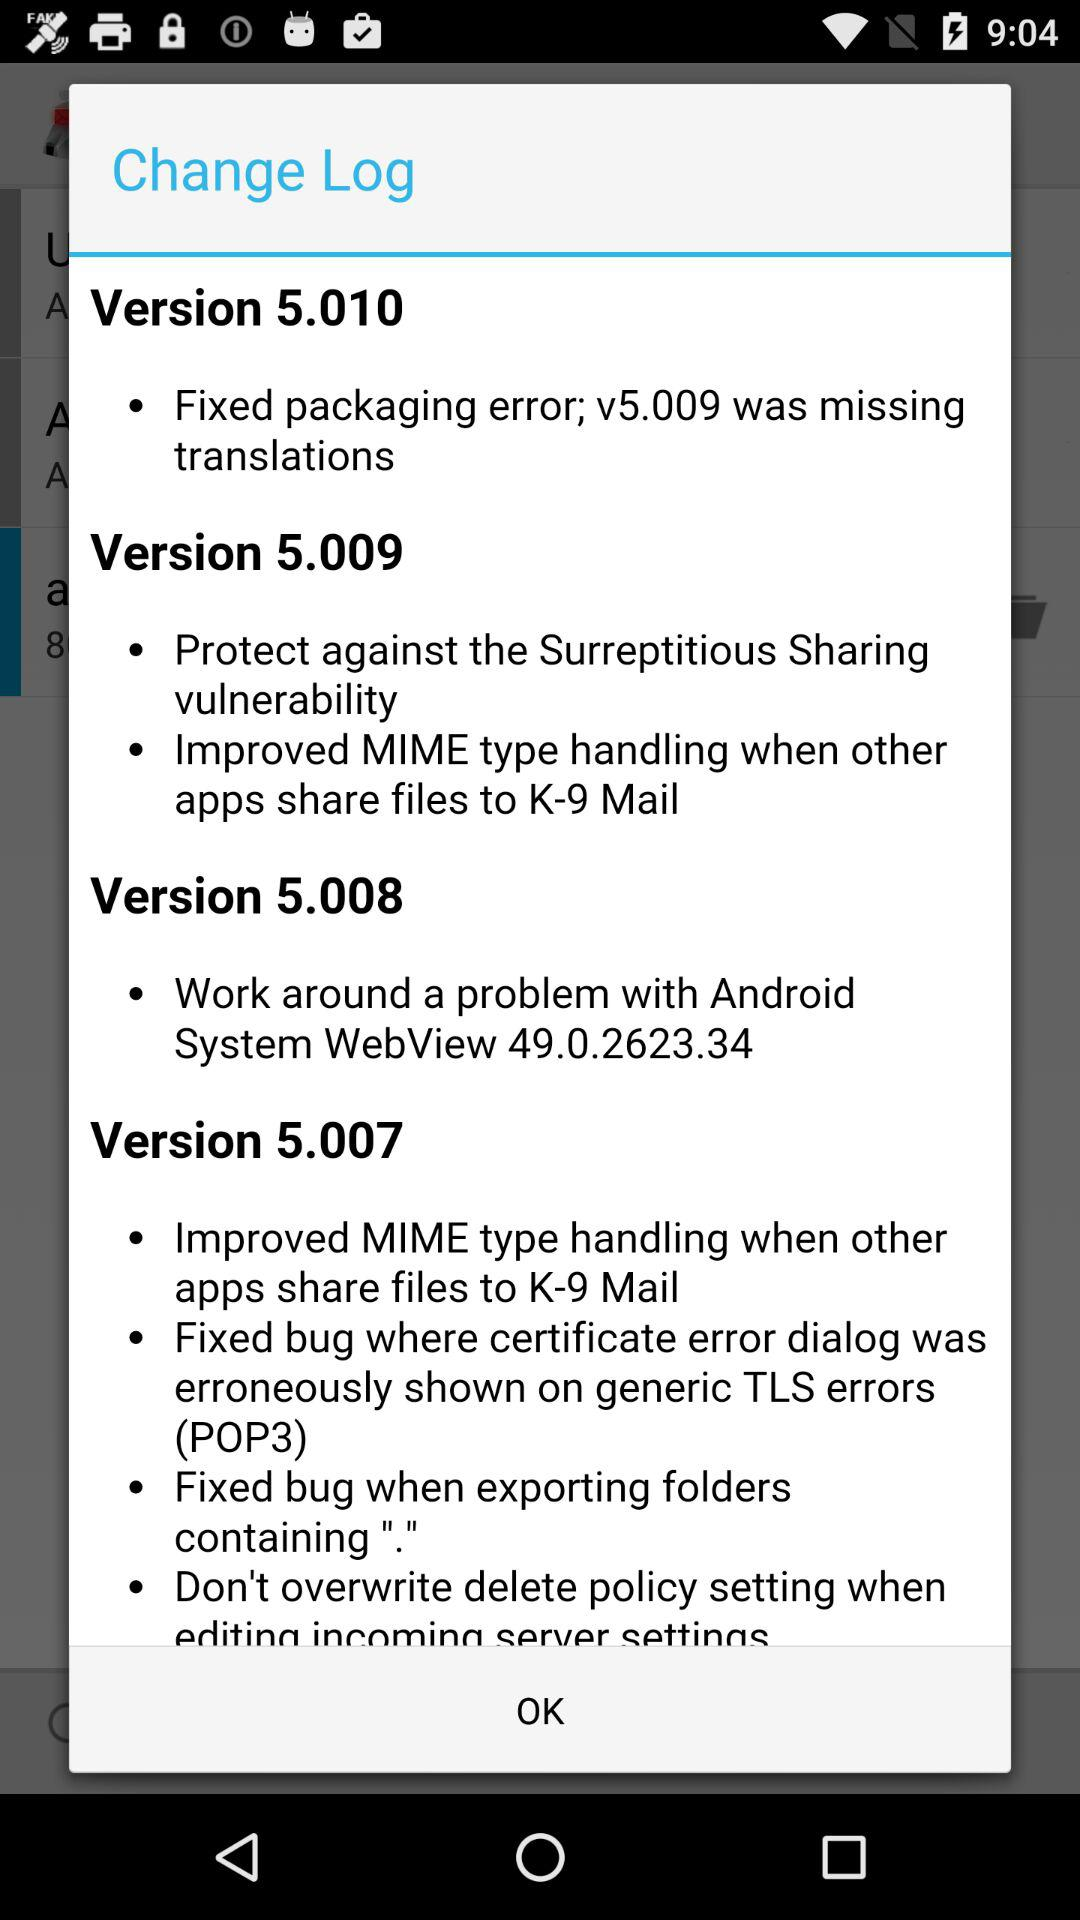What changes were made in version 5.010? The changes were "Fixed packaging error; v5.009 was missing translations". 